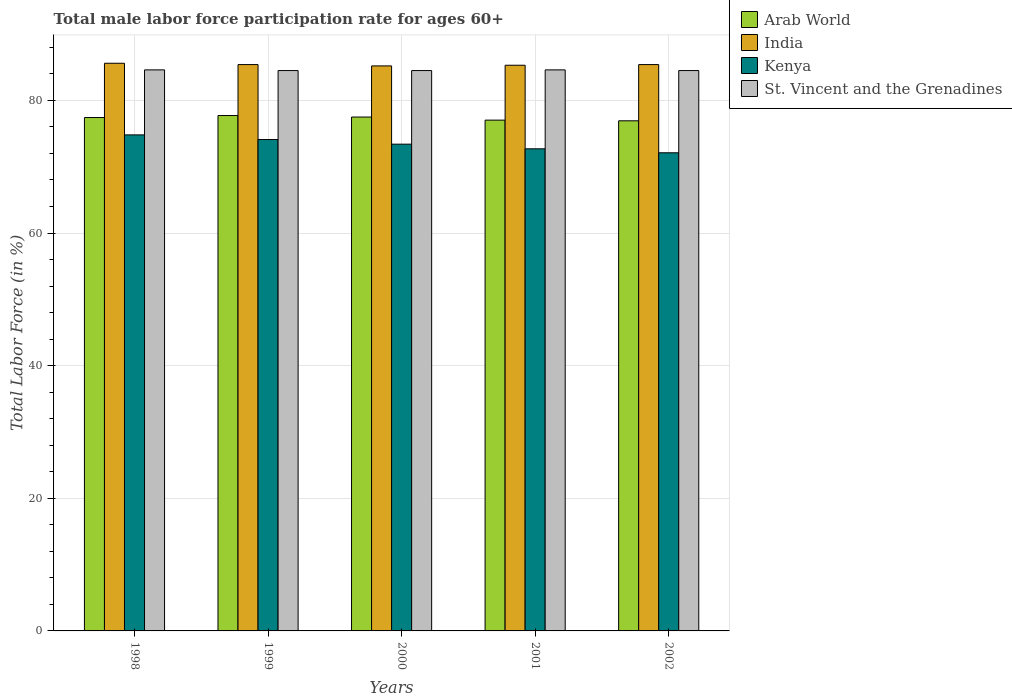Are the number of bars per tick equal to the number of legend labels?
Keep it short and to the point. Yes. How many bars are there on the 3rd tick from the left?
Offer a very short reply. 4. How many bars are there on the 2nd tick from the right?
Provide a short and direct response. 4. What is the label of the 5th group of bars from the left?
Your answer should be very brief. 2002. What is the male labor force participation rate in Arab World in 2000?
Give a very brief answer. 77.49. Across all years, what is the maximum male labor force participation rate in Arab World?
Offer a terse response. 77.72. Across all years, what is the minimum male labor force participation rate in India?
Your answer should be compact. 85.2. In which year was the male labor force participation rate in Arab World minimum?
Ensure brevity in your answer.  2002. What is the total male labor force participation rate in Kenya in the graph?
Give a very brief answer. 367.1. What is the difference between the male labor force participation rate in Kenya in 1998 and that in 2000?
Provide a succinct answer. 1.4. What is the difference between the male labor force participation rate in Arab World in 1998 and the male labor force participation rate in Kenya in 2001?
Keep it short and to the point. 4.71. What is the average male labor force participation rate in St. Vincent and the Grenadines per year?
Offer a very short reply. 84.54. In the year 1999, what is the difference between the male labor force participation rate in Arab World and male labor force participation rate in Kenya?
Provide a succinct answer. 3.62. In how many years, is the male labor force participation rate in India greater than 84 %?
Make the answer very short. 5. What is the ratio of the male labor force participation rate in Arab World in 1998 to that in 2002?
Offer a very short reply. 1.01. What is the difference between the highest and the second highest male labor force participation rate in Kenya?
Make the answer very short. 0.7. What is the difference between the highest and the lowest male labor force participation rate in Arab World?
Your response must be concise. 0.79. In how many years, is the male labor force participation rate in St. Vincent and the Grenadines greater than the average male labor force participation rate in St. Vincent and the Grenadines taken over all years?
Your answer should be very brief. 2. Is it the case that in every year, the sum of the male labor force participation rate in St. Vincent and the Grenadines and male labor force participation rate in Arab World is greater than the sum of male labor force participation rate in India and male labor force participation rate in Kenya?
Your answer should be very brief. Yes. What does the 3rd bar from the left in 1999 represents?
Ensure brevity in your answer.  Kenya. What does the 1st bar from the right in 2001 represents?
Your answer should be very brief. St. Vincent and the Grenadines. How many bars are there?
Offer a very short reply. 20. Are the values on the major ticks of Y-axis written in scientific E-notation?
Offer a very short reply. No. How many legend labels are there?
Keep it short and to the point. 4. What is the title of the graph?
Give a very brief answer. Total male labor force participation rate for ages 60+. Does "Andorra" appear as one of the legend labels in the graph?
Provide a succinct answer. No. What is the Total Labor Force (in %) in Arab World in 1998?
Keep it short and to the point. 77.41. What is the Total Labor Force (in %) in India in 1998?
Your response must be concise. 85.6. What is the Total Labor Force (in %) in Kenya in 1998?
Ensure brevity in your answer.  74.8. What is the Total Labor Force (in %) in St. Vincent and the Grenadines in 1998?
Your answer should be very brief. 84.6. What is the Total Labor Force (in %) of Arab World in 1999?
Give a very brief answer. 77.72. What is the Total Labor Force (in %) in India in 1999?
Keep it short and to the point. 85.4. What is the Total Labor Force (in %) of Kenya in 1999?
Provide a short and direct response. 74.1. What is the Total Labor Force (in %) of St. Vincent and the Grenadines in 1999?
Make the answer very short. 84.5. What is the Total Labor Force (in %) in Arab World in 2000?
Provide a succinct answer. 77.49. What is the Total Labor Force (in %) of India in 2000?
Your response must be concise. 85.2. What is the Total Labor Force (in %) in Kenya in 2000?
Provide a short and direct response. 73.4. What is the Total Labor Force (in %) of St. Vincent and the Grenadines in 2000?
Give a very brief answer. 84.5. What is the Total Labor Force (in %) of Arab World in 2001?
Give a very brief answer. 77.02. What is the Total Labor Force (in %) in India in 2001?
Your answer should be compact. 85.3. What is the Total Labor Force (in %) in Kenya in 2001?
Make the answer very short. 72.7. What is the Total Labor Force (in %) of St. Vincent and the Grenadines in 2001?
Give a very brief answer. 84.6. What is the Total Labor Force (in %) in Arab World in 2002?
Your answer should be very brief. 76.92. What is the Total Labor Force (in %) in India in 2002?
Your response must be concise. 85.4. What is the Total Labor Force (in %) of Kenya in 2002?
Provide a succinct answer. 72.1. What is the Total Labor Force (in %) in St. Vincent and the Grenadines in 2002?
Provide a short and direct response. 84.5. Across all years, what is the maximum Total Labor Force (in %) in Arab World?
Offer a terse response. 77.72. Across all years, what is the maximum Total Labor Force (in %) in India?
Give a very brief answer. 85.6. Across all years, what is the maximum Total Labor Force (in %) in Kenya?
Ensure brevity in your answer.  74.8. Across all years, what is the maximum Total Labor Force (in %) of St. Vincent and the Grenadines?
Provide a succinct answer. 84.6. Across all years, what is the minimum Total Labor Force (in %) of Arab World?
Provide a short and direct response. 76.92. Across all years, what is the minimum Total Labor Force (in %) in India?
Offer a very short reply. 85.2. Across all years, what is the minimum Total Labor Force (in %) of Kenya?
Make the answer very short. 72.1. Across all years, what is the minimum Total Labor Force (in %) in St. Vincent and the Grenadines?
Give a very brief answer. 84.5. What is the total Total Labor Force (in %) of Arab World in the graph?
Provide a short and direct response. 386.57. What is the total Total Labor Force (in %) in India in the graph?
Provide a succinct answer. 426.9. What is the total Total Labor Force (in %) in Kenya in the graph?
Offer a terse response. 367.1. What is the total Total Labor Force (in %) in St. Vincent and the Grenadines in the graph?
Keep it short and to the point. 422.7. What is the difference between the Total Labor Force (in %) in Arab World in 1998 and that in 1999?
Make the answer very short. -0.3. What is the difference between the Total Labor Force (in %) in India in 1998 and that in 1999?
Ensure brevity in your answer.  0.2. What is the difference between the Total Labor Force (in %) in Kenya in 1998 and that in 1999?
Offer a terse response. 0.7. What is the difference between the Total Labor Force (in %) in St. Vincent and the Grenadines in 1998 and that in 1999?
Provide a succinct answer. 0.1. What is the difference between the Total Labor Force (in %) in Arab World in 1998 and that in 2000?
Your answer should be compact. -0.08. What is the difference between the Total Labor Force (in %) in India in 1998 and that in 2000?
Your answer should be very brief. 0.4. What is the difference between the Total Labor Force (in %) of Kenya in 1998 and that in 2000?
Offer a very short reply. 1.4. What is the difference between the Total Labor Force (in %) of Arab World in 1998 and that in 2001?
Provide a succinct answer. 0.39. What is the difference between the Total Labor Force (in %) of India in 1998 and that in 2001?
Offer a terse response. 0.3. What is the difference between the Total Labor Force (in %) of St. Vincent and the Grenadines in 1998 and that in 2001?
Offer a very short reply. 0. What is the difference between the Total Labor Force (in %) in Arab World in 1998 and that in 2002?
Provide a succinct answer. 0.49. What is the difference between the Total Labor Force (in %) of Arab World in 1999 and that in 2000?
Your answer should be very brief. 0.22. What is the difference between the Total Labor Force (in %) of India in 1999 and that in 2000?
Offer a terse response. 0.2. What is the difference between the Total Labor Force (in %) in Kenya in 1999 and that in 2000?
Provide a succinct answer. 0.7. What is the difference between the Total Labor Force (in %) in Arab World in 1999 and that in 2001?
Ensure brevity in your answer.  0.69. What is the difference between the Total Labor Force (in %) in India in 1999 and that in 2001?
Your response must be concise. 0.1. What is the difference between the Total Labor Force (in %) of Kenya in 1999 and that in 2001?
Provide a short and direct response. 1.4. What is the difference between the Total Labor Force (in %) of Arab World in 1999 and that in 2002?
Provide a short and direct response. 0.79. What is the difference between the Total Labor Force (in %) of Kenya in 1999 and that in 2002?
Provide a succinct answer. 2. What is the difference between the Total Labor Force (in %) of Arab World in 2000 and that in 2001?
Offer a very short reply. 0.47. What is the difference between the Total Labor Force (in %) of Kenya in 2000 and that in 2001?
Offer a terse response. 0.7. What is the difference between the Total Labor Force (in %) in St. Vincent and the Grenadines in 2000 and that in 2001?
Ensure brevity in your answer.  -0.1. What is the difference between the Total Labor Force (in %) of Arab World in 2000 and that in 2002?
Ensure brevity in your answer.  0.57. What is the difference between the Total Labor Force (in %) of Kenya in 2000 and that in 2002?
Your answer should be compact. 1.3. What is the difference between the Total Labor Force (in %) in St. Vincent and the Grenadines in 2000 and that in 2002?
Offer a terse response. 0. What is the difference between the Total Labor Force (in %) of Arab World in 2001 and that in 2002?
Your answer should be compact. 0.1. What is the difference between the Total Labor Force (in %) in Arab World in 1998 and the Total Labor Force (in %) in India in 1999?
Provide a short and direct response. -7.99. What is the difference between the Total Labor Force (in %) of Arab World in 1998 and the Total Labor Force (in %) of Kenya in 1999?
Offer a very short reply. 3.31. What is the difference between the Total Labor Force (in %) in Arab World in 1998 and the Total Labor Force (in %) in St. Vincent and the Grenadines in 1999?
Offer a terse response. -7.09. What is the difference between the Total Labor Force (in %) in India in 1998 and the Total Labor Force (in %) in Kenya in 1999?
Offer a very short reply. 11.5. What is the difference between the Total Labor Force (in %) of India in 1998 and the Total Labor Force (in %) of St. Vincent and the Grenadines in 1999?
Keep it short and to the point. 1.1. What is the difference between the Total Labor Force (in %) of Kenya in 1998 and the Total Labor Force (in %) of St. Vincent and the Grenadines in 1999?
Offer a very short reply. -9.7. What is the difference between the Total Labor Force (in %) in Arab World in 1998 and the Total Labor Force (in %) in India in 2000?
Ensure brevity in your answer.  -7.79. What is the difference between the Total Labor Force (in %) in Arab World in 1998 and the Total Labor Force (in %) in Kenya in 2000?
Provide a succinct answer. 4.01. What is the difference between the Total Labor Force (in %) of Arab World in 1998 and the Total Labor Force (in %) of St. Vincent and the Grenadines in 2000?
Ensure brevity in your answer.  -7.09. What is the difference between the Total Labor Force (in %) of Kenya in 1998 and the Total Labor Force (in %) of St. Vincent and the Grenadines in 2000?
Provide a short and direct response. -9.7. What is the difference between the Total Labor Force (in %) in Arab World in 1998 and the Total Labor Force (in %) in India in 2001?
Give a very brief answer. -7.89. What is the difference between the Total Labor Force (in %) of Arab World in 1998 and the Total Labor Force (in %) of Kenya in 2001?
Your answer should be compact. 4.71. What is the difference between the Total Labor Force (in %) of Arab World in 1998 and the Total Labor Force (in %) of St. Vincent and the Grenadines in 2001?
Your answer should be very brief. -7.19. What is the difference between the Total Labor Force (in %) in India in 1998 and the Total Labor Force (in %) in Kenya in 2001?
Give a very brief answer. 12.9. What is the difference between the Total Labor Force (in %) in India in 1998 and the Total Labor Force (in %) in St. Vincent and the Grenadines in 2001?
Your response must be concise. 1. What is the difference between the Total Labor Force (in %) in Arab World in 1998 and the Total Labor Force (in %) in India in 2002?
Keep it short and to the point. -7.99. What is the difference between the Total Labor Force (in %) in Arab World in 1998 and the Total Labor Force (in %) in Kenya in 2002?
Keep it short and to the point. 5.31. What is the difference between the Total Labor Force (in %) of Arab World in 1998 and the Total Labor Force (in %) of St. Vincent and the Grenadines in 2002?
Offer a very short reply. -7.09. What is the difference between the Total Labor Force (in %) in India in 1998 and the Total Labor Force (in %) in St. Vincent and the Grenadines in 2002?
Offer a very short reply. 1.1. What is the difference between the Total Labor Force (in %) of Arab World in 1999 and the Total Labor Force (in %) of India in 2000?
Ensure brevity in your answer.  -7.48. What is the difference between the Total Labor Force (in %) in Arab World in 1999 and the Total Labor Force (in %) in Kenya in 2000?
Provide a succinct answer. 4.32. What is the difference between the Total Labor Force (in %) of Arab World in 1999 and the Total Labor Force (in %) of St. Vincent and the Grenadines in 2000?
Your answer should be compact. -6.78. What is the difference between the Total Labor Force (in %) of India in 1999 and the Total Labor Force (in %) of Kenya in 2000?
Your answer should be very brief. 12. What is the difference between the Total Labor Force (in %) in Kenya in 1999 and the Total Labor Force (in %) in St. Vincent and the Grenadines in 2000?
Offer a very short reply. -10.4. What is the difference between the Total Labor Force (in %) of Arab World in 1999 and the Total Labor Force (in %) of India in 2001?
Keep it short and to the point. -7.58. What is the difference between the Total Labor Force (in %) of Arab World in 1999 and the Total Labor Force (in %) of Kenya in 2001?
Your answer should be compact. 5.02. What is the difference between the Total Labor Force (in %) in Arab World in 1999 and the Total Labor Force (in %) in St. Vincent and the Grenadines in 2001?
Your answer should be very brief. -6.88. What is the difference between the Total Labor Force (in %) of India in 1999 and the Total Labor Force (in %) of Kenya in 2001?
Offer a terse response. 12.7. What is the difference between the Total Labor Force (in %) of India in 1999 and the Total Labor Force (in %) of St. Vincent and the Grenadines in 2001?
Provide a short and direct response. 0.8. What is the difference between the Total Labor Force (in %) in Arab World in 1999 and the Total Labor Force (in %) in India in 2002?
Make the answer very short. -7.68. What is the difference between the Total Labor Force (in %) in Arab World in 1999 and the Total Labor Force (in %) in Kenya in 2002?
Offer a terse response. 5.62. What is the difference between the Total Labor Force (in %) of Arab World in 1999 and the Total Labor Force (in %) of St. Vincent and the Grenadines in 2002?
Your answer should be very brief. -6.78. What is the difference between the Total Labor Force (in %) in India in 1999 and the Total Labor Force (in %) in Kenya in 2002?
Ensure brevity in your answer.  13.3. What is the difference between the Total Labor Force (in %) of India in 1999 and the Total Labor Force (in %) of St. Vincent and the Grenadines in 2002?
Your answer should be compact. 0.9. What is the difference between the Total Labor Force (in %) in Kenya in 1999 and the Total Labor Force (in %) in St. Vincent and the Grenadines in 2002?
Ensure brevity in your answer.  -10.4. What is the difference between the Total Labor Force (in %) of Arab World in 2000 and the Total Labor Force (in %) of India in 2001?
Provide a short and direct response. -7.81. What is the difference between the Total Labor Force (in %) in Arab World in 2000 and the Total Labor Force (in %) in Kenya in 2001?
Your response must be concise. 4.79. What is the difference between the Total Labor Force (in %) in Arab World in 2000 and the Total Labor Force (in %) in St. Vincent and the Grenadines in 2001?
Make the answer very short. -7.11. What is the difference between the Total Labor Force (in %) in India in 2000 and the Total Labor Force (in %) in Kenya in 2001?
Ensure brevity in your answer.  12.5. What is the difference between the Total Labor Force (in %) in India in 2000 and the Total Labor Force (in %) in St. Vincent and the Grenadines in 2001?
Provide a short and direct response. 0.6. What is the difference between the Total Labor Force (in %) of Arab World in 2000 and the Total Labor Force (in %) of India in 2002?
Your answer should be very brief. -7.91. What is the difference between the Total Labor Force (in %) in Arab World in 2000 and the Total Labor Force (in %) in Kenya in 2002?
Offer a terse response. 5.39. What is the difference between the Total Labor Force (in %) in Arab World in 2000 and the Total Labor Force (in %) in St. Vincent and the Grenadines in 2002?
Your answer should be very brief. -7.01. What is the difference between the Total Labor Force (in %) of India in 2000 and the Total Labor Force (in %) of Kenya in 2002?
Make the answer very short. 13.1. What is the difference between the Total Labor Force (in %) in Kenya in 2000 and the Total Labor Force (in %) in St. Vincent and the Grenadines in 2002?
Make the answer very short. -11.1. What is the difference between the Total Labor Force (in %) of Arab World in 2001 and the Total Labor Force (in %) of India in 2002?
Ensure brevity in your answer.  -8.38. What is the difference between the Total Labor Force (in %) in Arab World in 2001 and the Total Labor Force (in %) in Kenya in 2002?
Your response must be concise. 4.92. What is the difference between the Total Labor Force (in %) in Arab World in 2001 and the Total Labor Force (in %) in St. Vincent and the Grenadines in 2002?
Give a very brief answer. -7.48. What is the difference between the Total Labor Force (in %) of India in 2001 and the Total Labor Force (in %) of St. Vincent and the Grenadines in 2002?
Ensure brevity in your answer.  0.8. What is the average Total Labor Force (in %) in Arab World per year?
Keep it short and to the point. 77.31. What is the average Total Labor Force (in %) in India per year?
Your answer should be compact. 85.38. What is the average Total Labor Force (in %) in Kenya per year?
Keep it short and to the point. 73.42. What is the average Total Labor Force (in %) in St. Vincent and the Grenadines per year?
Offer a very short reply. 84.54. In the year 1998, what is the difference between the Total Labor Force (in %) in Arab World and Total Labor Force (in %) in India?
Your response must be concise. -8.19. In the year 1998, what is the difference between the Total Labor Force (in %) in Arab World and Total Labor Force (in %) in Kenya?
Keep it short and to the point. 2.61. In the year 1998, what is the difference between the Total Labor Force (in %) in Arab World and Total Labor Force (in %) in St. Vincent and the Grenadines?
Provide a succinct answer. -7.19. In the year 1998, what is the difference between the Total Labor Force (in %) in India and Total Labor Force (in %) in Kenya?
Keep it short and to the point. 10.8. In the year 1998, what is the difference between the Total Labor Force (in %) of India and Total Labor Force (in %) of St. Vincent and the Grenadines?
Provide a short and direct response. 1. In the year 1998, what is the difference between the Total Labor Force (in %) of Kenya and Total Labor Force (in %) of St. Vincent and the Grenadines?
Your answer should be very brief. -9.8. In the year 1999, what is the difference between the Total Labor Force (in %) in Arab World and Total Labor Force (in %) in India?
Your response must be concise. -7.68. In the year 1999, what is the difference between the Total Labor Force (in %) of Arab World and Total Labor Force (in %) of Kenya?
Offer a very short reply. 3.62. In the year 1999, what is the difference between the Total Labor Force (in %) of Arab World and Total Labor Force (in %) of St. Vincent and the Grenadines?
Offer a very short reply. -6.78. In the year 1999, what is the difference between the Total Labor Force (in %) in India and Total Labor Force (in %) in Kenya?
Your answer should be compact. 11.3. In the year 1999, what is the difference between the Total Labor Force (in %) in India and Total Labor Force (in %) in St. Vincent and the Grenadines?
Your response must be concise. 0.9. In the year 2000, what is the difference between the Total Labor Force (in %) in Arab World and Total Labor Force (in %) in India?
Offer a terse response. -7.71. In the year 2000, what is the difference between the Total Labor Force (in %) of Arab World and Total Labor Force (in %) of Kenya?
Your response must be concise. 4.09. In the year 2000, what is the difference between the Total Labor Force (in %) of Arab World and Total Labor Force (in %) of St. Vincent and the Grenadines?
Offer a terse response. -7.01. In the year 2000, what is the difference between the Total Labor Force (in %) in India and Total Labor Force (in %) in St. Vincent and the Grenadines?
Make the answer very short. 0.7. In the year 2001, what is the difference between the Total Labor Force (in %) of Arab World and Total Labor Force (in %) of India?
Your answer should be very brief. -8.28. In the year 2001, what is the difference between the Total Labor Force (in %) of Arab World and Total Labor Force (in %) of Kenya?
Your answer should be compact. 4.32. In the year 2001, what is the difference between the Total Labor Force (in %) of Arab World and Total Labor Force (in %) of St. Vincent and the Grenadines?
Provide a short and direct response. -7.58. In the year 2001, what is the difference between the Total Labor Force (in %) in India and Total Labor Force (in %) in Kenya?
Your answer should be very brief. 12.6. In the year 2001, what is the difference between the Total Labor Force (in %) in Kenya and Total Labor Force (in %) in St. Vincent and the Grenadines?
Your answer should be very brief. -11.9. In the year 2002, what is the difference between the Total Labor Force (in %) of Arab World and Total Labor Force (in %) of India?
Your response must be concise. -8.48. In the year 2002, what is the difference between the Total Labor Force (in %) in Arab World and Total Labor Force (in %) in Kenya?
Keep it short and to the point. 4.82. In the year 2002, what is the difference between the Total Labor Force (in %) in Arab World and Total Labor Force (in %) in St. Vincent and the Grenadines?
Offer a very short reply. -7.58. In the year 2002, what is the difference between the Total Labor Force (in %) in India and Total Labor Force (in %) in Kenya?
Your response must be concise. 13.3. What is the ratio of the Total Labor Force (in %) in Kenya in 1998 to that in 1999?
Give a very brief answer. 1.01. What is the ratio of the Total Labor Force (in %) in St. Vincent and the Grenadines in 1998 to that in 1999?
Your response must be concise. 1. What is the ratio of the Total Labor Force (in %) in Arab World in 1998 to that in 2000?
Your response must be concise. 1. What is the ratio of the Total Labor Force (in %) in Kenya in 1998 to that in 2000?
Your response must be concise. 1.02. What is the ratio of the Total Labor Force (in %) of St. Vincent and the Grenadines in 1998 to that in 2000?
Provide a short and direct response. 1. What is the ratio of the Total Labor Force (in %) of India in 1998 to that in 2001?
Keep it short and to the point. 1. What is the ratio of the Total Labor Force (in %) in Kenya in 1998 to that in 2001?
Your response must be concise. 1.03. What is the ratio of the Total Labor Force (in %) in Arab World in 1998 to that in 2002?
Make the answer very short. 1.01. What is the ratio of the Total Labor Force (in %) in India in 1998 to that in 2002?
Keep it short and to the point. 1. What is the ratio of the Total Labor Force (in %) of Kenya in 1998 to that in 2002?
Give a very brief answer. 1.04. What is the ratio of the Total Labor Force (in %) of Kenya in 1999 to that in 2000?
Offer a terse response. 1.01. What is the ratio of the Total Labor Force (in %) of Arab World in 1999 to that in 2001?
Make the answer very short. 1.01. What is the ratio of the Total Labor Force (in %) in India in 1999 to that in 2001?
Make the answer very short. 1. What is the ratio of the Total Labor Force (in %) of Kenya in 1999 to that in 2001?
Your answer should be compact. 1.02. What is the ratio of the Total Labor Force (in %) of St. Vincent and the Grenadines in 1999 to that in 2001?
Provide a succinct answer. 1. What is the ratio of the Total Labor Force (in %) in Arab World in 1999 to that in 2002?
Provide a succinct answer. 1.01. What is the ratio of the Total Labor Force (in %) in Kenya in 1999 to that in 2002?
Provide a short and direct response. 1.03. What is the ratio of the Total Labor Force (in %) in Kenya in 2000 to that in 2001?
Offer a very short reply. 1.01. What is the ratio of the Total Labor Force (in %) of St. Vincent and the Grenadines in 2000 to that in 2001?
Offer a terse response. 1. What is the ratio of the Total Labor Force (in %) in Arab World in 2000 to that in 2002?
Your response must be concise. 1.01. What is the ratio of the Total Labor Force (in %) in Kenya in 2000 to that in 2002?
Your answer should be very brief. 1.02. What is the ratio of the Total Labor Force (in %) of St. Vincent and the Grenadines in 2000 to that in 2002?
Keep it short and to the point. 1. What is the ratio of the Total Labor Force (in %) in India in 2001 to that in 2002?
Your answer should be very brief. 1. What is the ratio of the Total Labor Force (in %) in Kenya in 2001 to that in 2002?
Your answer should be compact. 1.01. What is the difference between the highest and the second highest Total Labor Force (in %) in Arab World?
Make the answer very short. 0.22. What is the difference between the highest and the second highest Total Labor Force (in %) in Kenya?
Keep it short and to the point. 0.7. What is the difference between the highest and the lowest Total Labor Force (in %) in Arab World?
Your answer should be compact. 0.79. What is the difference between the highest and the lowest Total Labor Force (in %) of India?
Make the answer very short. 0.4. What is the difference between the highest and the lowest Total Labor Force (in %) in Kenya?
Offer a very short reply. 2.7. 